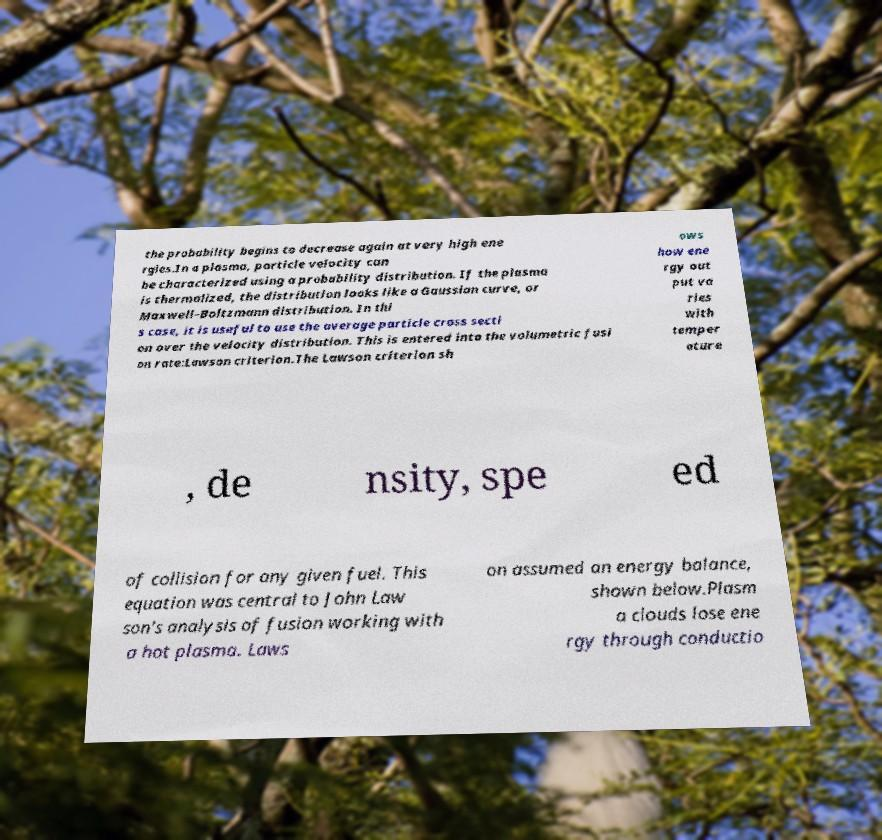Can you accurately transcribe the text from the provided image for me? the probability begins to decrease again at very high ene rgies.In a plasma, particle velocity can be characterized using a probability distribution. If the plasma is thermalized, the distribution looks like a Gaussian curve, or Maxwell–Boltzmann distribution. In thi s case, it is useful to use the average particle cross secti on over the velocity distribution. This is entered into the volumetric fusi on rate:Lawson criterion.The Lawson criterion sh ows how ene rgy out put va ries with temper ature , de nsity, spe ed of collision for any given fuel. This equation was central to John Law son's analysis of fusion working with a hot plasma. Laws on assumed an energy balance, shown below.Plasm a clouds lose ene rgy through conductio 